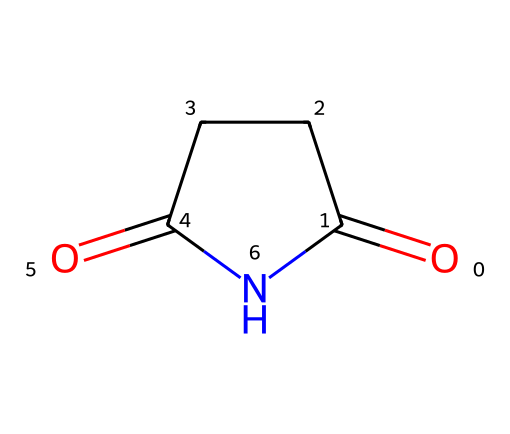What is the molecular formula of succinimide? To determine the molecular formula, we analyze the SMILES representation. The composition contains carbon (C), oxygen (O), and nitrogen (N) atoms. Counting from the structure gives us 4 carbon atoms, 4 hydrogen atoms, 2 oxygen atoms, and 1 nitrogen atom, resulting in the formula C4H5NO2.
Answer: C4H5NO2 How many rings are present in the structure of succinimide? The SMILES representation shows that there is a cyclic structure indicated by the 'C1' and 'N1' which suggests a ring formation. Therefore, we can conclude there is one ring present.
Answer: one What type of bonding is present in succinimide between the nitrogen and carbon atoms? The structure displays a single bond between the nitrogen atom and a carbon atom in the ring. Analyzing the connectivity shows that it is a single covalent bond through the nitrogen's lone pair.
Answer: single covalent bond What functional groups are present in succinimide? By examining the SMILES structure, we can note the presence of a cyclic imide functional group characterized by the carbonyl groups (C=O) adjacent to the nitrogen. Thus, the primary functional group in succinimide is the imide functional group.
Answer: imide What is the total number of atoms in succinimide? To find the total number of atoms, we count all the atoms represented in the SMILES notation: 4 carbon, 5 hydrogen, 2 oxygen, and 1 nitrogen, totaling 12 atoms in the molecule.
Answer: 12 